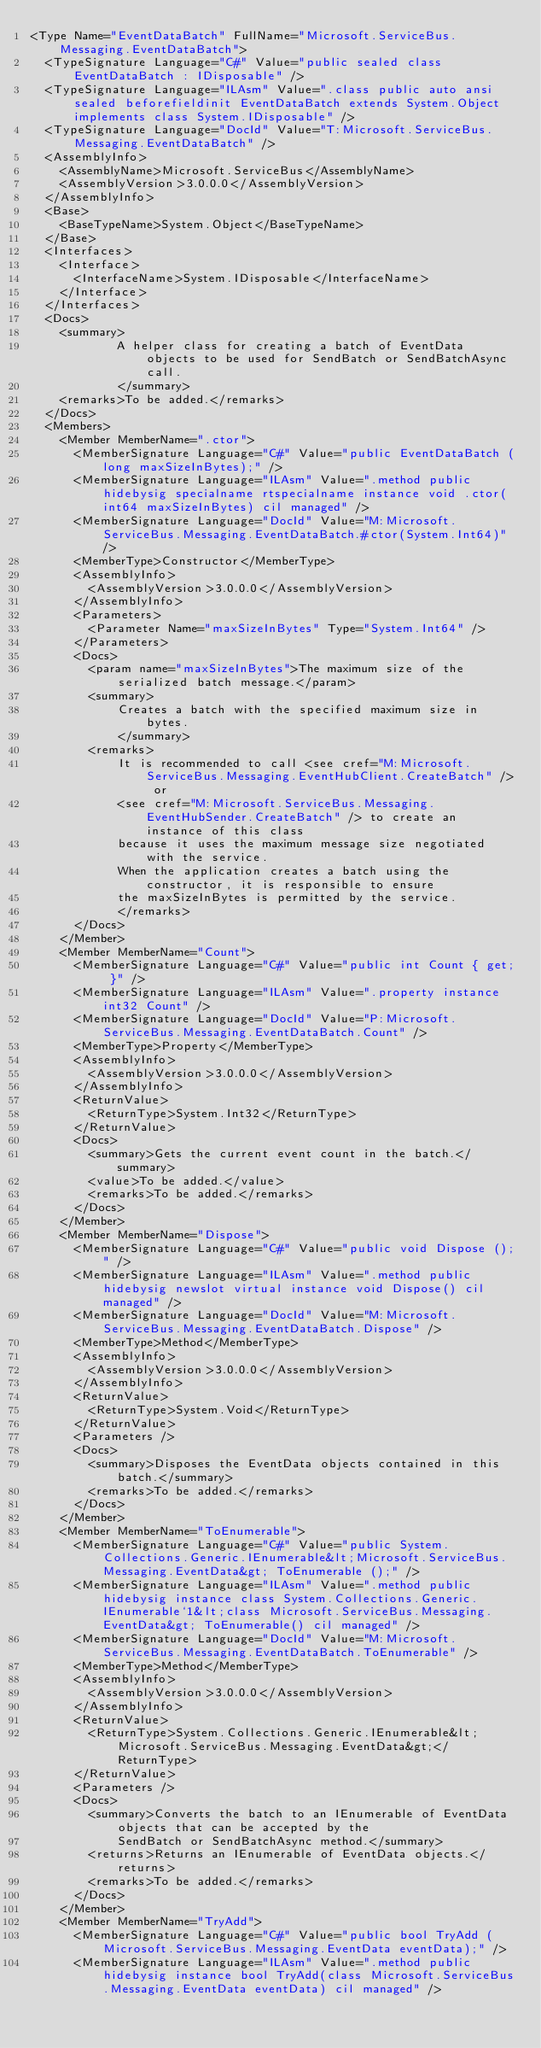<code> <loc_0><loc_0><loc_500><loc_500><_XML_><Type Name="EventDataBatch" FullName="Microsoft.ServiceBus.Messaging.EventDataBatch">
  <TypeSignature Language="C#" Value="public sealed class EventDataBatch : IDisposable" />
  <TypeSignature Language="ILAsm" Value=".class public auto ansi sealed beforefieldinit EventDataBatch extends System.Object implements class System.IDisposable" />
  <TypeSignature Language="DocId" Value="T:Microsoft.ServiceBus.Messaging.EventDataBatch" />
  <AssemblyInfo>
    <AssemblyName>Microsoft.ServiceBus</AssemblyName>
    <AssemblyVersion>3.0.0.0</AssemblyVersion>
  </AssemblyInfo>
  <Base>
    <BaseTypeName>System.Object</BaseTypeName>
  </Base>
  <Interfaces>
    <Interface>
      <InterfaceName>System.IDisposable</InterfaceName>
    </Interface>
  </Interfaces>
  <Docs>
    <summary>
            A helper class for creating a batch of EventData objects to be used for SendBatch or SendBatchAsync call.
            </summary>
    <remarks>To be added.</remarks>
  </Docs>
  <Members>
    <Member MemberName=".ctor">
      <MemberSignature Language="C#" Value="public EventDataBatch (long maxSizeInBytes);" />
      <MemberSignature Language="ILAsm" Value=".method public hidebysig specialname rtspecialname instance void .ctor(int64 maxSizeInBytes) cil managed" />
      <MemberSignature Language="DocId" Value="M:Microsoft.ServiceBus.Messaging.EventDataBatch.#ctor(System.Int64)" />
      <MemberType>Constructor</MemberType>
      <AssemblyInfo>
        <AssemblyVersion>3.0.0.0</AssemblyVersion>
      </AssemblyInfo>
      <Parameters>
        <Parameter Name="maxSizeInBytes" Type="System.Int64" />
      </Parameters>
      <Docs>
        <param name="maxSizeInBytes">The maximum size of the serialized batch message.</param>
        <summary>
            Creates a batch with the specified maximum size in bytes.
            </summary>
        <remarks>
            It is recommended to call <see cref="M:Microsoft.ServiceBus.Messaging.EventHubClient.CreateBatch" /> or
            <see cref="M:Microsoft.ServiceBus.Messaging.EventHubSender.CreateBatch" /> to create an instance of this class
            because it uses the maximum message size negotiated with the service.
            When the application creates a batch using the constructor, it is responsible to ensure
            the maxSizeInBytes is permitted by the service.
            </remarks>
      </Docs>
    </Member>
    <Member MemberName="Count">
      <MemberSignature Language="C#" Value="public int Count { get; }" />
      <MemberSignature Language="ILAsm" Value=".property instance int32 Count" />
      <MemberSignature Language="DocId" Value="P:Microsoft.ServiceBus.Messaging.EventDataBatch.Count" />
      <MemberType>Property</MemberType>
      <AssemblyInfo>
        <AssemblyVersion>3.0.0.0</AssemblyVersion>
      </AssemblyInfo>
      <ReturnValue>
        <ReturnType>System.Int32</ReturnType>
      </ReturnValue>
      <Docs>
        <summary>Gets the current event count in the batch.</summary>
        <value>To be added.</value>
        <remarks>To be added.</remarks>
      </Docs>
    </Member>
    <Member MemberName="Dispose">
      <MemberSignature Language="C#" Value="public void Dispose ();" />
      <MemberSignature Language="ILAsm" Value=".method public hidebysig newslot virtual instance void Dispose() cil managed" />
      <MemberSignature Language="DocId" Value="M:Microsoft.ServiceBus.Messaging.EventDataBatch.Dispose" />
      <MemberType>Method</MemberType>
      <AssemblyInfo>
        <AssemblyVersion>3.0.0.0</AssemblyVersion>
      </AssemblyInfo>
      <ReturnValue>
        <ReturnType>System.Void</ReturnType>
      </ReturnValue>
      <Parameters />
      <Docs>
        <summary>Disposes the EventData objects contained in this batch.</summary>
        <remarks>To be added.</remarks>
      </Docs>
    </Member>
    <Member MemberName="ToEnumerable">
      <MemberSignature Language="C#" Value="public System.Collections.Generic.IEnumerable&lt;Microsoft.ServiceBus.Messaging.EventData&gt; ToEnumerable ();" />
      <MemberSignature Language="ILAsm" Value=".method public hidebysig instance class System.Collections.Generic.IEnumerable`1&lt;class Microsoft.ServiceBus.Messaging.EventData&gt; ToEnumerable() cil managed" />
      <MemberSignature Language="DocId" Value="M:Microsoft.ServiceBus.Messaging.EventDataBatch.ToEnumerable" />
      <MemberType>Method</MemberType>
      <AssemblyInfo>
        <AssemblyVersion>3.0.0.0</AssemblyVersion>
      </AssemblyInfo>
      <ReturnValue>
        <ReturnType>System.Collections.Generic.IEnumerable&lt;Microsoft.ServiceBus.Messaging.EventData&gt;</ReturnType>
      </ReturnValue>
      <Parameters />
      <Docs>
        <summary>Converts the batch to an IEnumerable of EventData objects that can be accepted by the
            SendBatch or SendBatchAsync method.</summary>
        <returns>Returns an IEnumerable of EventData objects.</returns>
        <remarks>To be added.</remarks>
      </Docs>
    </Member>
    <Member MemberName="TryAdd">
      <MemberSignature Language="C#" Value="public bool TryAdd (Microsoft.ServiceBus.Messaging.EventData eventData);" />
      <MemberSignature Language="ILAsm" Value=".method public hidebysig instance bool TryAdd(class Microsoft.ServiceBus.Messaging.EventData eventData) cil managed" /></code> 